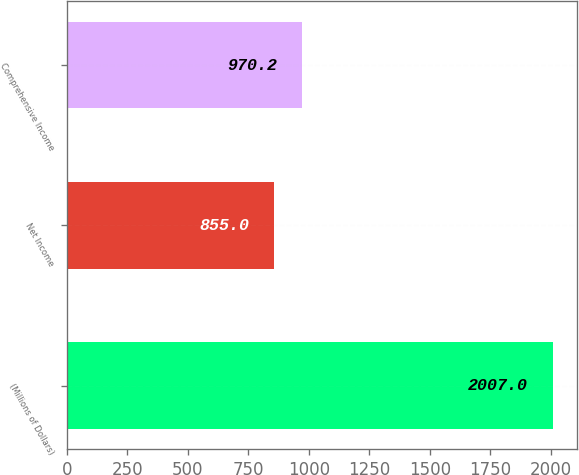Convert chart to OTSL. <chart><loc_0><loc_0><loc_500><loc_500><bar_chart><fcel>(Millions of Dollars)<fcel>Net Income<fcel>Comprehensive Income<nl><fcel>2007<fcel>855<fcel>970.2<nl></chart> 